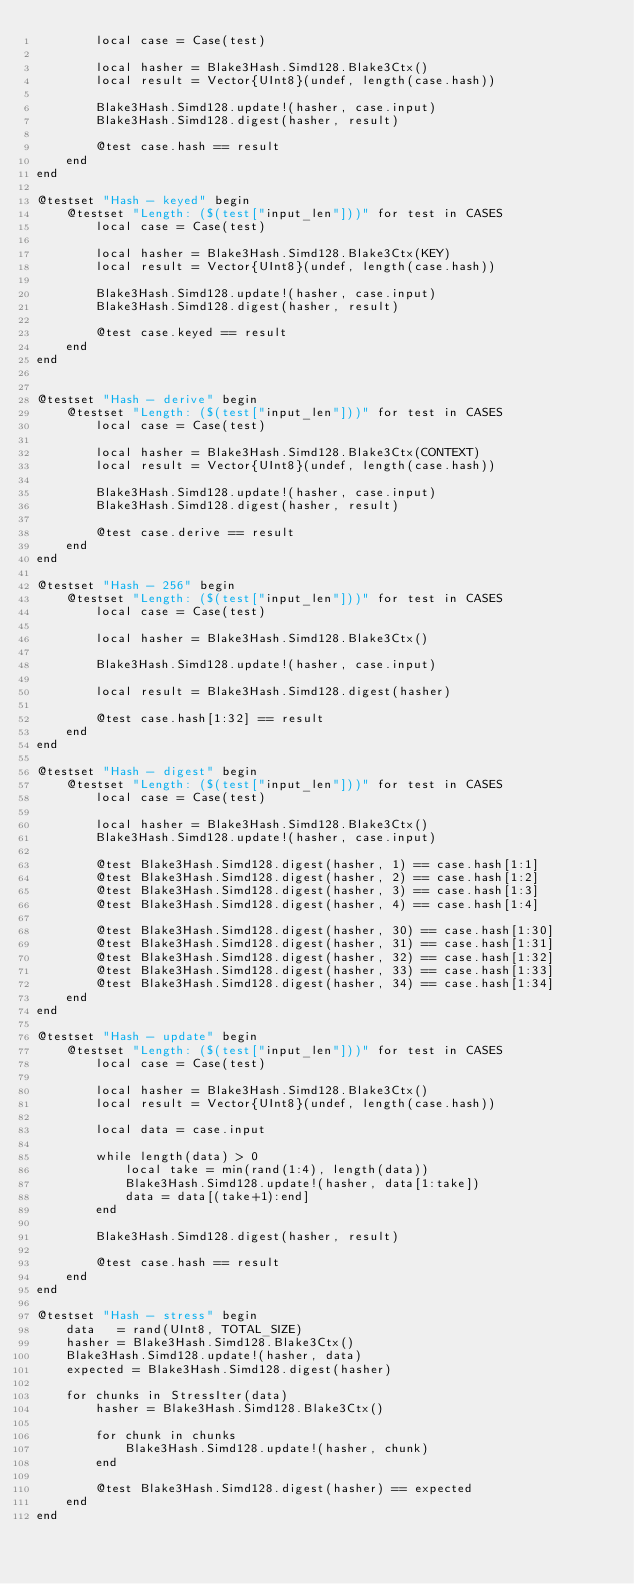<code> <loc_0><loc_0><loc_500><loc_500><_Julia_>        local case = Case(test)

        local hasher = Blake3Hash.Simd128.Blake3Ctx()
        local result = Vector{UInt8}(undef, length(case.hash))

        Blake3Hash.Simd128.update!(hasher, case.input)
        Blake3Hash.Simd128.digest(hasher, result)

        @test case.hash == result
    end
end

@testset "Hash - keyed" begin
    @testset "Length: ($(test["input_len"]))" for test in CASES
        local case = Case(test)

        local hasher = Blake3Hash.Simd128.Blake3Ctx(KEY)
        local result = Vector{UInt8}(undef, length(case.hash))

        Blake3Hash.Simd128.update!(hasher, case.input)
        Blake3Hash.Simd128.digest(hasher, result)

        @test case.keyed == result
    end
end


@testset "Hash - derive" begin
    @testset "Length: ($(test["input_len"]))" for test in CASES
        local case = Case(test)

        local hasher = Blake3Hash.Simd128.Blake3Ctx(CONTEXT)
        local result = Vector{UInt8}(undef, length(case.hash))

        Blake3Hash.Simd128.update!(hasher, case.input)
        Blake3Hash.Simd128.digest(hasher, result)

        @test case.derive == result
    end
end

@testset "Hash - 256" begin
    @testset "Length: ($(test["input_len"]))" for test in CASES
        local case = Case(test)

        local hasher = Blake3Hash.Simd128.Blake3Ctx()

        Blake3Hash.Simd128.update!(hasher, case.input)

        local result = Blake3Hash.Simd128.digest(hasher)

        @test case.hash[1:32] == result
    end
end

@testset "Hash - digest" begin
    @testset "Length: ($(test["input_len"]))" for test in CASES
        local case = Case(test)

        local hasher = Blake3Hash.Simd128.Blake3Ctx()
        Blake3Hash.Simd128.update!(hasher, case.input)

        @test Blake3Hash.Simd128.digest(hasher, 1) == case.hash[1:1]
        @test Blake3Hash.Simd128.digest(hasher, 2) == case.hash[1:2]
        @test Blake3Hash.Simd128.digest(hasher, 3) == case.hash[1:3]
        @test Blake3Hash.Simd128.digest(hasher, 4) == case.hash[1:4]

        @test Blake3Hash.Simd128.digest(hasher, 30) == case.hash[1:30]
        @test Blake3Hash.Simd128.digest(hasher, 31) == case.hash[1:31]
        @test Blake3Hash.Simd128.digest(hasher, 32) == case.hash[1:32]
        @test Blake3Hash.Simd128.digest(hasher, 33) == case.hash[1:33]
        @test Blake3Hash.Simd128.digest(hasher, 34) == case.hash[1:34]
    end
end

@testset "Hash - update" begin
    @testset "Length: ($(test["input_len"]))" for test in CASES
        local case = Case(test)

        local hasher = Blake3Hash.Simd128.Blake3Ctx()
        local result = Vector{UInt8}(undef, length(case.hash))

        local data = case.input

        while length(data) > 0
            local take = min(rand(1:4), length(data))
            Blake3Hash.Simd128.update!(hasher, data[1:take])
            data = data[(take+1):end]
        end

        Blake3Hash.Simd128.digest(hasher, result)

        @test case.hash == result
    end
end

@testset "Hash - stress" begin
    data   = rand(UInt8, TOTAL_SIZE)
    hasher = Blake3Hash.Simd128.Blake3Ctx()
    Blake3Hash.Simd128.update!(hasher, data)
    expected = Blake3Hash.Simd128.digest(hasher)

    for chunks in StressIter(data)
        hasher = Blake3Hash.Simd128.Blake3Ctx()

        for chunk in chunks
            Blake3Hash.Simd128.update!(hasher, chunk)
        end

        @test Blake3Hash.Simd128.digest(hasher) == expected
    end
end
</code> 